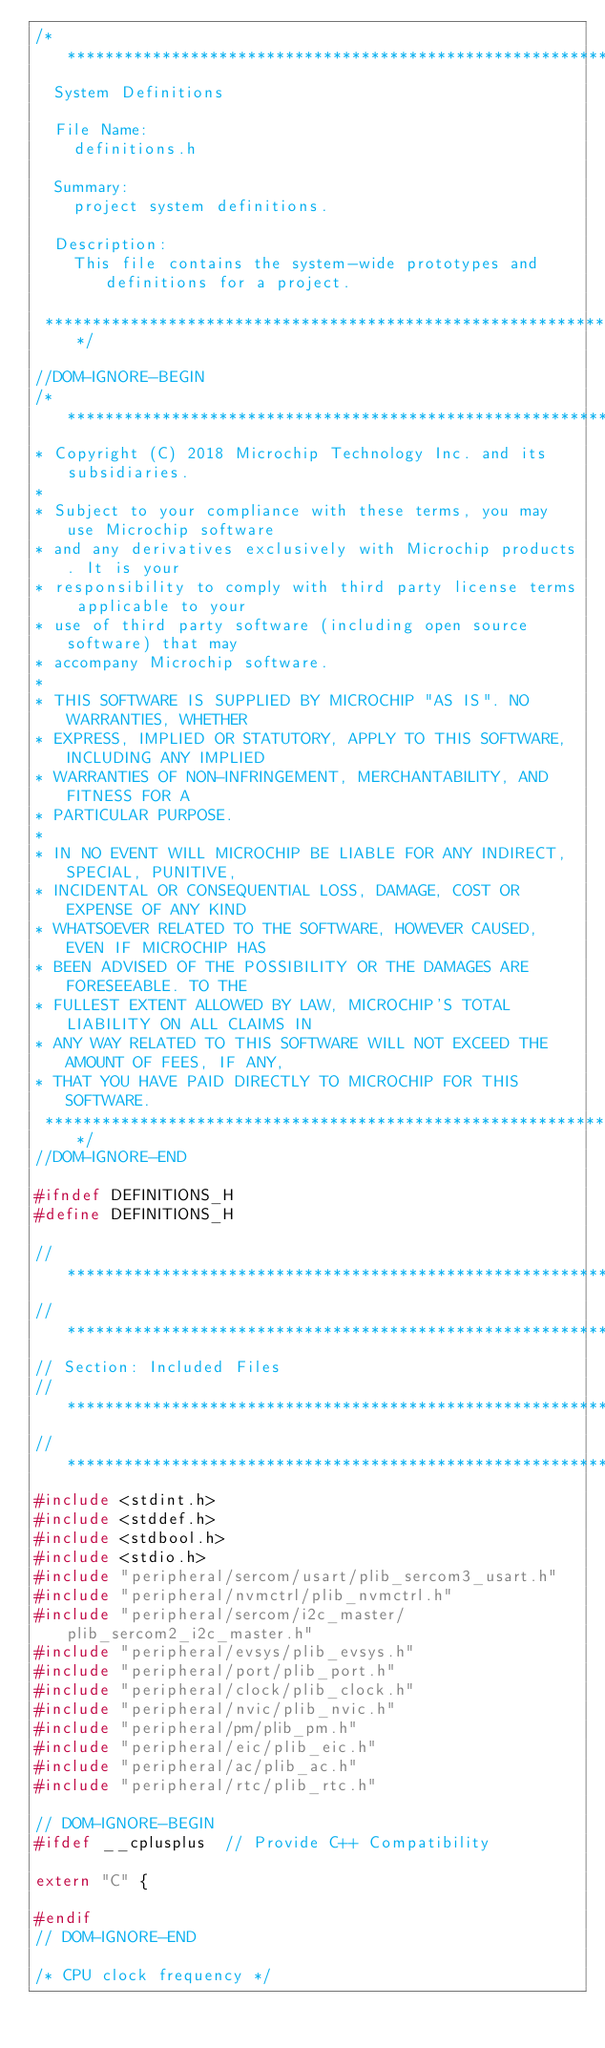Convert code to text. <code><loc_0><loc_0><loc_500><loc_500><_C_>/*******************************************************************************
  System Definitions

  File Name:
    definitions.h

  Summary:
    project system definitions.

  Description:
    This file contains the system-wide prototypes and definitions for a project.

 *******************************************************************************/

//DOM-IGNORE-BEGIN
/*******************************************************************************
* Copyright (C) 2018 Microchip Technology Inc. and its subsidiaries.
*
* Subject to your compliance with these terms, you may use Microchip software
* and any derivatives exclusively with Microchip products. It is your
* responsibility to comply with third party license terms applicable to your
* use of third party software (including open source software) that may
* accompany Microchip software.
*
* THIS SOFTWARE IS SUPPLIED BY MICROCHIP "AS IS". NO WARRANTIES, WHETHER
* EXPRESS, IMPLIED OR STATUTORY, APPLY TO THIS SOFTWARE, INCLUDING ANY IMPLIED
* WARRANTIES OF NON-INFRINGEMENT, MERCHANTABILITY, AND FITNESS FOR A
* PARTICULAR PURPOSE.
*
* IN NO EVENT WILL MICROCHIP BE LIABLE FOR ANY INDIRECT, SPECIAL, PUNITIVE,
* INCIDENTAL OR CONSEQUENTIAL LOSS, DAMAGE, COST OR EXPENSE OF ANY KIND
* WHATSOEVER RELATED TO THE SOFTWARE, HOWEVER CAUSED, EVEN IF MICROCHIP HAS
* BEEN ADVISED OF THE POSSIBILITY OR THE DAMAGES ARE FORESEEABLE. TO THE
* FULLEST EXTENT ALLOWED BY LAW, MICROCHIP'S TOTAL LIABILITY ON ALL CLAIMS IN
* ANY WAY RELATED TO THIS SOFTWARE WILL NOT EXCEED THE AMOUNT OF FEES, IF ANY,
* THAT YOU HAVE PAID DIRECTLY TO MICROCHIP FOR THIS SOFTWARE.
 *******************************************************************************/
//DOM-IGNORE-END

#ifndef DEFINITIONS_H
#define DEFINITIONS_H

// *****************************************************************************
// *****************************************************************************
// Section: Included Files
// *****************************************************************************
// *****************************************************************************
#include <stdint.h>
#include <stddef.h>
#include <stdbool.h>
#include <stdio.h>
#include "peripheral/sercom/usart/plib_sercom3_usart.h"
#include "peripheral/nvmctrl/plib_nvmctrl.h"
#include "peripheral/sercom/i2c_master/plib_sercom2_i2c_master.h"
#include "peripheral/evsys/plib_evsys.h"
#include "peripheral/port/plib_port.h"
#include "peripheral/clock/plib_clock.h"
#include "peripheral/nvic/plib_nvic.h"
#include "peripheral/pm/plib_pm.h"
#include "peripheral/eic/plib_eic.h"
#include "peripheral/ac/plib_ac.h"
#include "peripheral/rtc/plib_rtc.h"

// DOM-IGNORE-BEGIN
#ifdef __cplusplus  // Provide C++ Compatibility

extern "C" {

#endif
// DOM-IGNORE-END

/* CPU clock frequency */</code> 